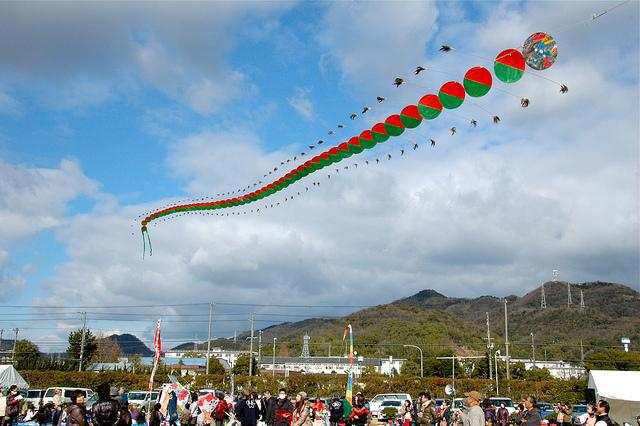Which one of these countries has a flag that is most similar to the kite?

Choices:
A) canada
B) bangladesh
C) peru
D) lithuania bangladesh 